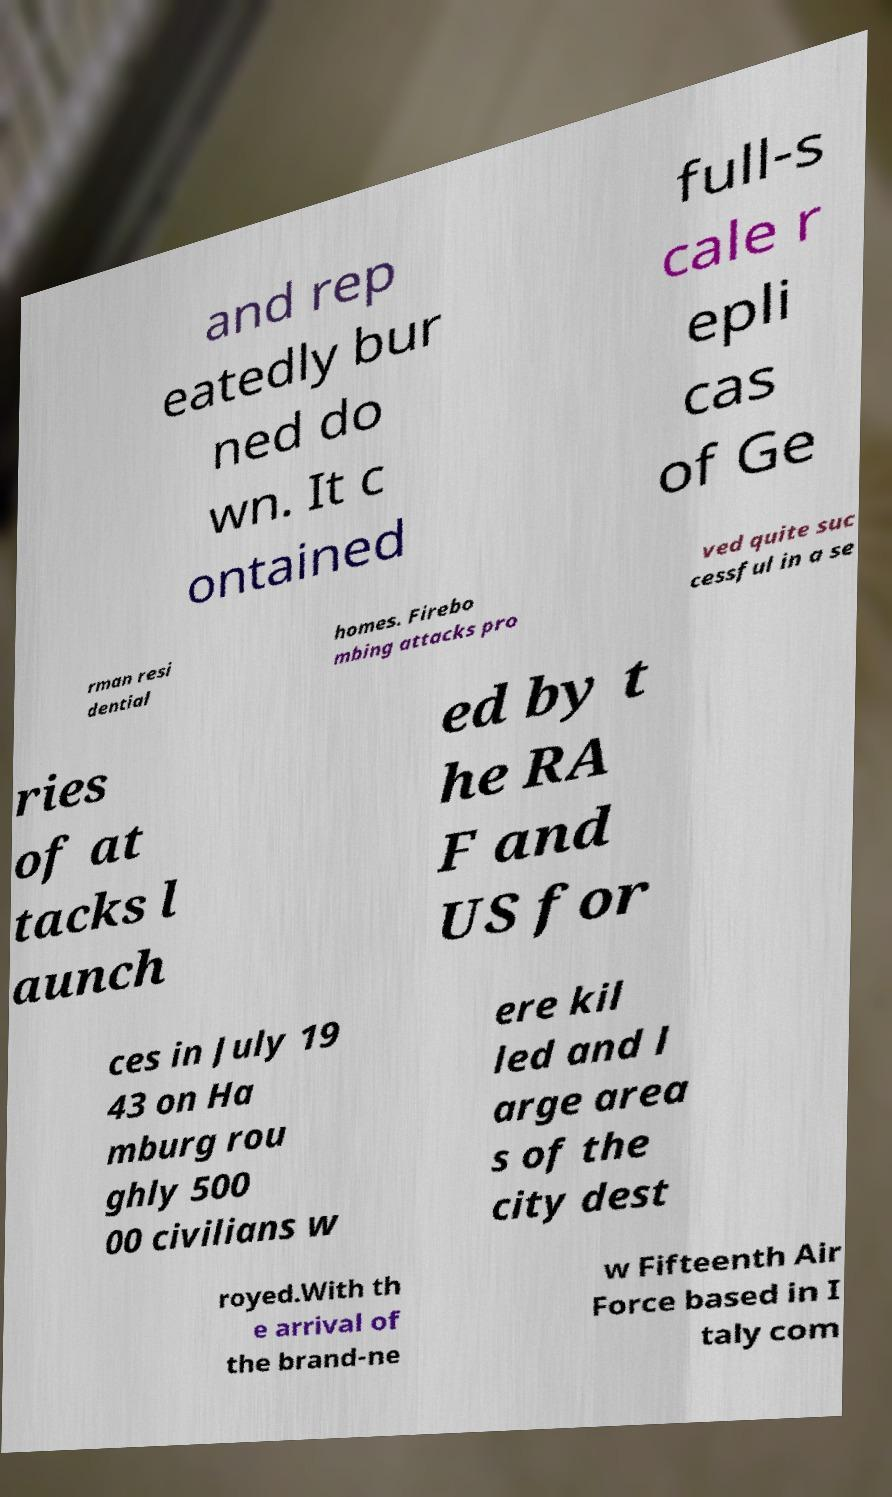Please read and relay the text visible in this image. What does it say? and rep eatedly bur ned do wn. It c ontained full-s cale r epli cas of Ge rman resi dential homes. Firebo mbing attacks pro ved quite suc cessful in a se ries of at tacks l aunch ed by t he RA F and US for ces in July 19 43 on Ha mburg rou ghly 500 00 civilians w ere kil led and l arge area s of the city dest royed.With th e arrival of the brand-ne w Fifteenth Air Force based in I taly com 